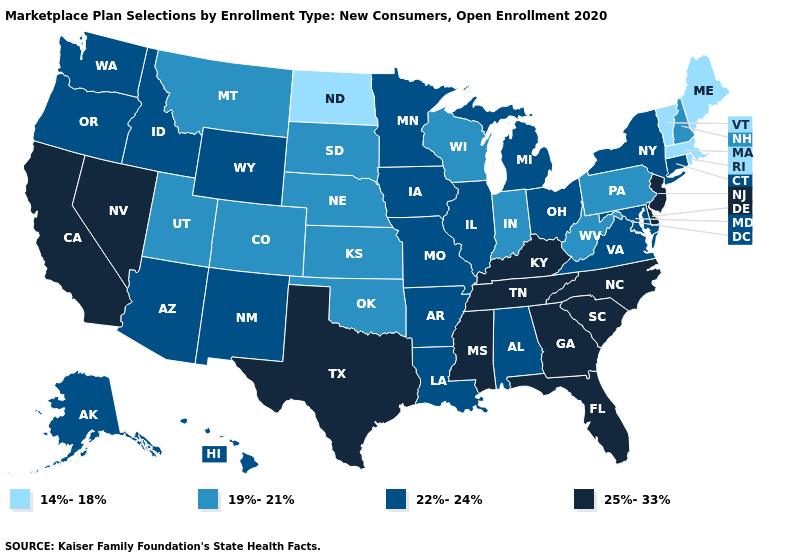What is the highest value in the USA?
Be succinct. 25%-33%. Does the first symbol in the legend represent the smallest category?
Be succinct. Yes. Which states have the highest value in the USA?
Short answer required. California, Delaware, Florida, Georgia, Kentucky, Mississippi, Nevada, New Jersey, North Carolina, South Carolina, Tennessee, Texas. What is the value of Wyoming?
Write a very short answer. 22%-24%. Which states have the lowest value in the Northeast?
Concise answer only. Maine, Massachusetts, Rhode Island, Vermont. Does Rhode Island have the lowest value in the USA?
Concise answer only. Yes. Which states hav the highest value in the Northeast?
Concise answer only. New Jersey. What is the value of North Dakota?
Short answer required. 14%-18%. Which states have the lowest value in the Northeast?
Give a very brief answer. Maine, Massachusetts, Rhode Island, Vermont. Does South Carolina have the highest value in the USA?
Short answer required. Yes. Which states have the lowest value in the USA?
Concise answer only. Maine, Massachusetts, North Dakota, Rhode Island, Vermont. Which states have the highest value in the USA?
Short answer required. California, Delaware, Florida, Georgia, Kentucky, Mississippi, Nevada, New Jersey, North Carolina, South Carolina, Tennessee, Texas. Name the states that have a value in the range 14%-18%?
Answer briefly. Maine, Massachusetts, North Dakota, Rhode Island, Vermont. Among the states that border Louisiana , which have the lowest value?
Write a very short answer. Arkansas. 